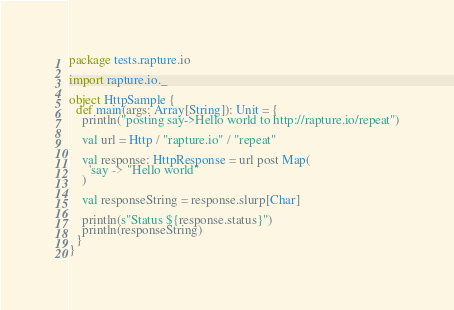<code> <loc_0><loc_0><loc_500><loc_500><_Scala_>package tests.rapture.io

import rapture.io._

object HttpSample {
  def main(args: Array[String]): Unit = {
    println("posting say->Hello world to http://rapture.io/repeat")

    val url = Http / "rapture.io" / "repeat"

    val response: HttpResponse = url post Map(
      'say -> "Hello world"
    )

    val responseString = response.slurp[Char]

    println(s"Status ${response.status}")
    println(responseString)
  }
}
</code> 